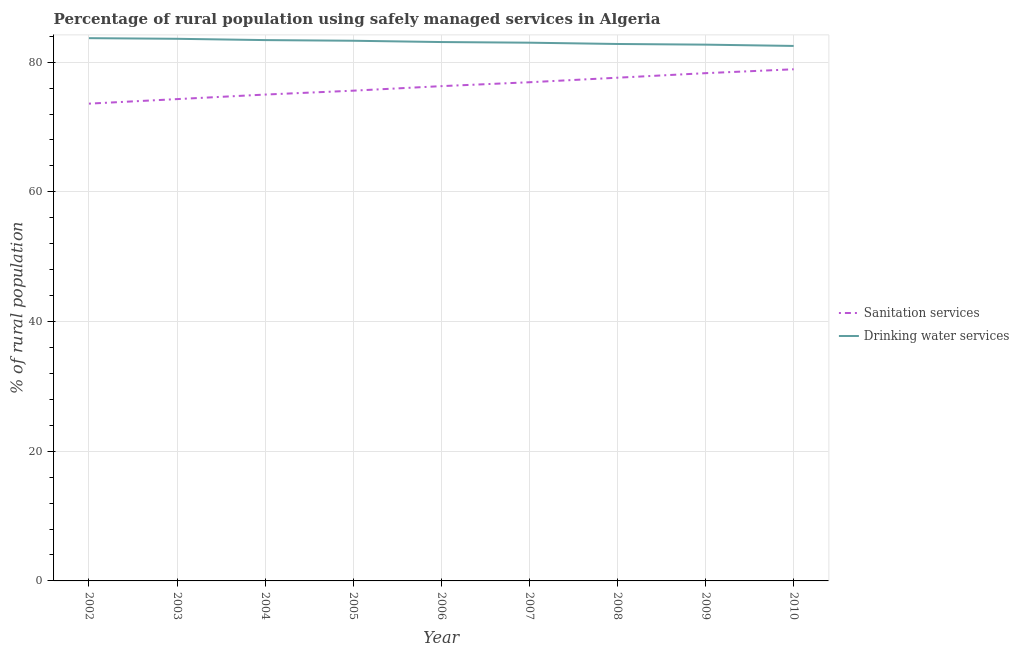What is the percentage of rural population who used sanitation services in 2006?
Provide a succinct answer. 76.3. Across all years, what is the maximum percentage of rural population who used drinking water services?
Provide a short and direct response. 83.7. Across all years, what is the minimum percentage of rural population who used sanitation services?
Offer a very short reply. 73.6. In which year was the percentage of rural population who used drinking water services maximum?
Ensure brevity in your answer.  2002. In which year was the percentage of rural population who used sanitation services minimum?
Your answer should be compact. 2002. What is the total percentage of rural population who used drinking water services in the graph?
Your response must be concise. 748.1. What is the difference between the percentage of rural population who used sanitation services in 2002 and that in 2007?
Give a very brief answer. -3.3. What is the difference between the percentage of rural population who used drinking water services in 2003 and the percentage of rural population who used sanitation services in 2002?
Ensure brevity in your answer.  10. What is the average percentage of rural population who used drinking water services per year?
Your answer should be very brief. 83.12. In the year 2004, what is the difference between the percentage of rural population who used drinking water services and percentage of rural population who used sanitation services?
Offer a terse response. 8.4. In how many years, is the percentage of rural population who used drinking water services greater than 4 %?
Your answer should be compact. 9. What is the ratio of the percentage of rural population who used drinking water services in 2004 to that in 2005?
Ensure brevity in your answer.  1. Is the percentage of rural population who used sanitation services in 2004 less than that in 2005?
Your response must be concise. Yes. What is the difference between the highest and the second highest percentage of rural population who used drinking water services?
Provide a short and direct response. 0.1. What is the difference between the highest and the lowest percentage of rural population who used drinking water services?
Give a very brief answer. 1.2. Is the sum of the percentage of rural population who used sanitation services in 2006 and 2007 greater than the maximum percentage of rural population who used drinking water services across all years?
Your answer should be very brief. Yes. Does the percentage of rural population who used sanitation services monotonically increase over the years?
Provide a succinct answer. Yes. Is the percentage of rural population who used sanitation services strictly greater than the percentage of rural population who used drinking water services over the years?
Make the answer very short. No. Is the percentage of rural population who used drinking water services strictly less than the percentage of rural population who used sanitation services over the years?
Ensure brevity in your answer.  No. How many lines are there?
Provide a short and direct response. 2. How many years are there in the graph?
Your response must be concise. 9. Does the graph contain any zero values?
Provide a short and direct response. No. Does the graph contain grids?
Provide a succinct answer. Yes. What is the title of the graph?
Offer a terse response. Percentage of rural population using safely managed services in Algeria. Does "Official aid received" appear as one of the legend labels in the graph?
Ensure brevity in your answer.  No. What is the label or title of the Y-axis?
Provide a short and direct response. % of rural population. What is the % of rural population in Sanitation services in 2002?
Offer a very short reply. 73.6. What is the % of rural population in Drinking water services in 2002?
Your answer should be very brief. 83.7. What is the % of rural population of Sanitation services in 2003?
Provide a succinct answer. 74.3. What is the % of rural population in Drinking water services in 2003?
Keep it short and to the point. 83.6. What is the % of rural population in Drinking water services in 2004?
Ensure brevity in your answer.  83.4. What is the % of rural population in Sanitation services in 2005?
Offer a very short reply. 75.6. What is the % of rural population in Drinking water services in 2005?
Ensure brevity in your answer.  83.3. What is the % of rural population in Sanitation services in 2006?
Your answer should be very brief. 76.3. What is the % of rural population in Drinking water services in 2006?
Provide a succinct answer. 83.1. What is the % of rural population in Sanitation services in 2007?
Your answer should be compact. 76.9. What is the % of rural population in Sanitation services in 2008?
Your answer should be compact. 77.6. What is the % of rural population in Drinking water services in 2008?
Offer a terse response. 82.8. What is the % of rural population of Sanitation services in 2009?
Your answer should be compact. 78.3. What is the % of rural population in Drinking water services in 2009?
Provide a succinct answer. 82.7. What is the % of rural population in Sanitation services in 2010?
Your answer should be compact. 78.9. What is the % of rural population of Drinking water services in 2010?
Offer a very short reply. 82.5. Across all years, what is the maximum % of rural population of Sanitation services?
Your response must be concise. 78.9. Across all years, what is the maximum % of rural population of Drinking water services?
Provide a short and direct response. 83.7. Across all years, what is the minimum % of rural population of Sanitation services?
Offer a very short reply. 73.6. Across all years, what is the minimum % of rural population in Drinking water services?
Offer a very short reply. 82.5. What is the total % of rural population of Sanitation services in the graph?
Give a very brief answer. 686.5. What is the total % of rural population of Drinking water services in the graph?
Your response must be concise. 748.1. What is the difference between the % of rural population of Sanitation services in 2002 and that in 2003?
Keep it short and to the point. -0.7. What is the difference between the % of rural population in Drinking water services in 2002 and that in 2003?
Keep it short and to the point. 0.1. What is the difference between the % of rural population in Sanitation services in 2002 and that in 2004?
Provide a succinct answer. -1.4. What is the difference between the % of rural population in Sanitation services in 2002 and that in 2005?
Offer a very short reply. -2. What is the difference between the % of rural population of Sanitation services in 2002 and that in 2006?
Ensure brevity in your answer.  -2.7. What is the difference between the % of rural population of Drinking water services in 2002 and that in 2007?
Offer a terse response. 0.7. What is the difference between the % of rural population of Sanitation services in 2002 and that in 2008?
Offer a terse response. -4. What is the difference between the % of rural population in Drinking water services in 2002 and that in 2009?
Provide a succinct answer. 1. What is the difference between the % of rural population in Drinking water services in 2002 and that in 2010?
Offer a terse response. 1.2. What is the difference between the % of rural population in Drinking water services in 2003 and that in 2005?
Provide a short and direct response. 0.3. What is the difference between the % of rural population of Sanitation services in 2003 and that in 2006?
Your response must be concise. -2. What is the difference between the % of rural population of Drinking water services in 2003 and that in 2007?
Offer a very short reply. 0.6. What is the difference between the % of rural population in Sanitation services in 2003 and that in 2009?
Provide a short and direct response. -4. What is the difference between the % of rural population of Drinking water services in 2003 and that in 2009?
Make the answer very short. 0.9. What is the difference between the % of rural population in Drinking water services in 2003 and that in 2010?
Offer a very short reply. 1.1. What is the difference between the % of rural population of Sanitation services in 2004 and that in 2005?
Ensure brevity in your answer.  -0.6. What is the difference between the % of rural population in Drinking water services in 2004 and that in 2005?
Provide a short and direct response. 0.1. What is the difference between the % of rural population of Drinking water services in 2004 and that in 2006?
Your answer should be very brief. 0.3. What is the difference between the % of rural population of Drinking water services in 2004 and that in 2007?
Make the answer very short. 0.4. What is the difference between the % of rural population of Drinking water services in 2004 and that in 2009?
Your answer should be very brief. 0.7. What is the difference between the % of rural population in Sanitation services in 2004 and that in 2010?
Your response must be concise. -3.9. What is the difference between the % of rural population of Drinking water services in 2004 and that in 2010?
Your response must be concise. 0.9. What is the difference between the % of rural population of Drinking water services in 2005 and that in 2006?
Provide a succinct answer. 0.2. What is the difference between the % of rural population in Sanitation services in 2005 and that in 2007?
Keep it short and to the point. -1.3. What is the difference between the % of rural population in Drinking water services in 2005 and that in 2009?
Make the answer very short. 0.6. What is the difference between the % of rural population of Drinking water services in 2005 and that in 2010?
Your answer should be compact. 0.8. What is the difference between the % of rural population of Sanitation services in 2006 and that in 2007?
Offer a very short reply. -0.6. What is the difference between the % of rural population in Drinking water services in 2006 and that in 2009?
Offer a terse response. 0.4. What is the difference between the % of rural population in Sanitation services in 2007 and that in 2009?
Provide a short and direct response. -1.4. What is the difference between the % of rural population in Drinking water services in 2007 and that in 2009?
Your answer should be compact. 0.3. What is the difference between the % of rural population in Sanitation services in 2007 and that in 2010?
Give a very brief answer. -2. What is the difference between the % of rural population of Drinking water services in 2008 and that in 2010?
Give a very brief answer. 0.3. What is the difference between the % of rural population of Drinking water services in 2009 and that in 2010?
Give a very brief answer. 0.2. What is the difference between the % of rural population of Sanitation services in 2002 and the % of rural population of Drinking water services in 2003?
Keep it short and to the point. -10. What is the difference between the % of rural population in Sanitation services in 2002 and the % of rural population in Drinking water services in 2004?
Your response must be concise. -9.8. What is the difference between the % of rural population in Sanitation services in 2002 and the % of rural population in Drinking water services in 2005?
Keep it short and to the point. -9.7. What is the difference between the % of rural population of Sanitation services in 2002 and the % of rural population of Drinking water services in 2010?
Give a very brief answer. -8.9. What is the difference between the % of rural population in Sanitation services in 2003 and the % of rural population in Drinking water services in 2004?
Provide a succinct answer. -9.1. What is the difference between the % of rural population in Sanitation services in 2003 and the % of rural population in Drinking water services in 2006?
Your answer should be compact. -8.8. What is the difference between the % of rural population of Sanitation services in 2003 and the % of rural population of Drinking water services in 2007?
Your answer should be very brief. -8.7. What is the difference between the % of rural population of Sanitation services in 2003 and the % of rural population of Drinking water services in 2008?
Provide a succinct answer. -8.5. What is the difference between the % of rural population in Sanitation services in 2004 and the % of rural population in Drinking water services in 2005?
Provide a succinct answer. -8.3. What is the difference between the % of rural population of Sanitation services in 2004 and the % of rural population of Drinking water services in 2006?
Keep it short and to the point. -8.1. What is the difference between the % of rural population of Sanitation services in 2004 and the % of rural population of Drinking water services in 2007?
Ensure brevity in your answer.  -8. What is the difference between the % of rural population in Sanitation services in 2004 and the % of rural population in Drinking water services in 2009?
Offer a terse response. -7.7. What is the difference between the % of rural population of Sanitation services in 2004 and the % of rural population of Drinking water services in 2010?
Offer a terse response. -7.5. What is the difference between the % of rural population of Sanitation services in 2005 and the % of rural population of Drinking water services in 2010?
Offer a terse response. -6.9. What is the difference between the % of rural population in Sanitation services in 2006 and the % of rural population in Drinking water services in 2009?
Provide a short and direct response. -6.4. What is the difference between the % of rural population of Sanitation services in 2006 and the % of rural population of Drinking water services in 2010?
Your answer should be compact. -6.2. What is the difference between the % of rural population in Sanitation services in 2008 and the % of rural population in Drinking water services in 2009?
Make the answer very short. -5.1. What is the difference between the % of rural population in Sanitation services in 2009 and the % of rural population in Drinking water services in 2010?
Keep it short and to the point. -4.2. What is the average % of rural population of Sanitation services per year?
Your answer should be compact. 76.28. What is the average % of rural population of Drinking water services per year?
Provide a short and direct response. 83.12. In the year 2002, what is the difference between the % of rural population of Sanitation services and % of rural population of Drinking water services?
Keep it short and to the point. -10.1. In the year 2003, what is the difference between the % of rural population of Sanitation services and % of rural population of Drinking water services?
Ensure brevity in your answer.  -9.3. In the year 2005, what is the difference between the % of rural population of Sanitation services and % of rural population of Drinking water services?
Provide a succinct answer. -7.7. In the year 2006, what is the difference between the % of rural population in Sanitation services and % of rural population in Drinking water services?
Provide a short and direct response. -6.8. In the year 2007, what is the difference between the % of rural population in Sanitation services and % of rural population in Drinking water services?
Your response must be concise. -6.1. In the year 2008, what is the difference between the % of rural population in Sanitation services and % of rural population in Drinking water services?
Ensure brevity in your answer.  -5.2. In the year 2009, what is the difference between the % of rural population in Sanitation services and % of rural population in Drinking water services?
Offer a very short reply. -4.4. In the year 2010, what is the difference between the % of rural population in Sanitation services and % of rural population in Drinking water services?
Provide a succinct answer. -3.6. What is the ratio of the % of rural population of Sanitation services in 2002 to that in 2003?
Your answer should be very brief. 0.99. What is the ratio of the % of rural population of Sanitation services in 2002 to that in 2004?
Make the answer very short. 0.98. What is the ratio of the % of rural population in Sanitation services in 2002 to that in 2005?
Provide a succinct answer. 0.97. What is the ratio of the % of rural population of Sanitation services in 2002 to that in 2006?
Provide a succinct answer. 0.96. What is the ratio of the % of rural population of Drinking water services in 2002 to that in 2006?
Ensure brevity in your answer.  1.01. What is the ratio of the % of rural population of Sanitation services in 2002 to that in 2007?
Keep it short and to the point. 0.96. What is the ratio of the % of rural population in Drinking water services in 2002 to that in 2007?
Keep it short and to the point. 1.01. What is the ratio of the % of rural population of Sanitation services in 2002 to that in 2008?
Offer a very short reply. 0.95. What is the ratio of the % of rural population in Drinking water services in 2002 to that in 2008?
Keep it short and to the point. 1.01. What is the ratio of the % of rural population in Sanitation services in 2002 to that in 2009?
Provide a succinct answer. 0.94. What is the ratio of the % of rural population of Drinking water services in 2002 to that in 2009?
Give a very brief answer. 1.01. What is the ratio of the % of rural population of Sanitation services in 2002 to that in 2010?
Offer a very short reply. 0.93. What is the ratio of the % of rural population of Drinking water services in 2002 to that in 2010?
Your answer should be compact. 1.01. What is the ratio of the % of rural population of Drinking water services in 2003 to that in 2004?
Offer a terse response. 1. What is the ratio of the % of rural population of Sanitation services in 2003 to that in 2005?
Provide a short and direct response. 0.98. What is the ratio of the % of rural population of Sanitation services in 2003 to that in 2006?
Provide a short and direct response. 0.97. What is the ratio of the % of rural population of Drinking water services in 2003 to that in 2006?
Make the answer very short. 1.01. What is the ratio of the % of rural population of Sanitation services in 2003 to that in 2007?
Offer a very short reply. 0.97. What is the ratio of the % of rural population of Drinking water services in 2003 to that in 2007?
Provide a short and direct response. 1.01. What is the ratio of the % of rural population of Sanitation services in 2003 to that in 2008?
Your response must be concise. 0.96. What is the ratio of the % of rural population in Drinking water services in 2003 to that in 2008?
Your answer should be compact. 1.01. What is the ratio of the % of rural population of Sanitation services in 2003 to that in 2009?
Your answer should be compact. 0.95. What is the ratio of the % of rural population of Drinking water services in 2003 to that in 2009?
Your answer should be compact. 1.01. What is the ratio of the % of rural population in Sanitation services in 2003 to that in 2010?
Give a very brief answer. 0.94. What is the ratio of the % of rural population in Drinking water services in 2003 to that in 2010?
Keep it short and to the point. 1.01. What is the ratio of the % of rural population in Sanitation services in 2004 to that in 2005?
Provide a succinct answer. 0.99. What is the ratio of the % of rural population in Sanitation services in 2004 to that in 2006?
Provide a succinct answer. 0.98. What is the ratio of the % of rural population of Drinking water services in 2004 to that in 2006?
Give a very brief answer. 1. What is the ratio of the % of rural population of Sanitation services in 2004 to that in 2007?
Provide a succinct answer. 0.98. What is the ratio of the % of rural population in Sanitation services in 2004 to that in 2008?
Offer a very short reply. 0.97. What is the ratio of the % of rural population in Drinking water services in 2004 to that in 2008?
Provide a succinct answer. 1.01. What is the ratio of the % of rural population of Sanitation services in 2004 to that in 2009?
Give a very brief answer. 0.96. What is the ratio of the % of rural population of Drinking water services in 2004 to that in 2009?
Offer a terse response. 1.01. What is the ratio of the % of rural population of Sanitation services in 2004 to that in 2010?
Offer a very short reply. 0.95. What is the ratio of the % of rural population of Drinking water services in 2004 to that in 2010?
Ensure brevity in your answer.  1.01. What is the ratio of the % of rural population in Drinking water services in 2005 to that in 2006?
Provide a succinct answer. 1. What is the ratio of the % of rural population in Sanitation services in 2005 to that in 2007?
Your answer should be very brief. 0.98. What is the ratio of the % of rural population in Sanitation services in 2005 to that in 2008?
Your answer should be compact. 0.97. What is the ratio of the % of rural population of Drinking water services in 2005 to that in 2008?
Your answer should be very brief. 1.01. What is the ratio of the % of rural population in Sanitation services in 2005 to that in 2009?
Keep it short and to the point. 0.97. What is the ratio of the % of rural population of Drinking water services in 2005 to that in 2009?
Keep it short and to the point. 1.01. What is the ratio of the % of rural population in Sanitation services in 2005 to that in 2010?
Your response must be concise. 0.96. What is the ratio of the % of rural population in Drinking water services in 2005 to that in 2010?
Ensure brevity in your answer.  1.01. What is the ratio of the % of rural population in Sanitation services in 2006 to that in 2007?
Provide a succinct answer. 0.99. What is the ratio of the % of rural population of Drinking water services in 2006 to that in 2007?
Ensure brevity in your answer.  1. What is the ratio of the % of rural population in Sanitation services in 2006 to that in 2008?
Provide a short and direct response. 0.98. What is the ratio of the % of rural population of Sanitation services in 2006 to that in 2009?
Offer a terse response. 0.97. What is the ratio of the % of rural population of Drinking water services in 2006 to that in 2010?
Keep it short and to the point. 1.01. What is the ratio of the % of rural population in Sanitation services in 2007 to that in 2008?
Your answer should be compact. 0.99. What is the ratio of the % of rural population in Sanitation services in 2007 to that in 2009?
Make the answer very short. 0.98. What is the ratio of the % of rural population of Sanitation services in 2007 to that in 2010?
Make the answer very short. 0.97. What is the ratio of the % of rural population in Drinking water services in 2008 to that in 2009?
Your response must be concise. 1. What is the ratio of the % of rural population in Sanitation services in 2008 to that in 2010?
Make the answer very short. 0.98. What is the difference between the highest and the second highest % of rural population of Sanitation services?
Ensure brevity in your answer.  0.6. What is the difference between the highest and the second highest % of rural population of Drinking water services?
Your answer should be compact. 0.1. What is the difference between the highest and the lowest % of rural population in Sanitation services?
Offer a terse response. 5.3. What is the difference between the highest and the lowest % of rural population of Drinking water services?
Ensure brevity in your answer.  1.2. 